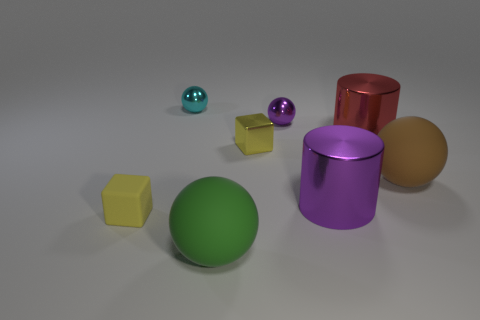Subtract 1 balls. How many balls are left? 3 Subtract all blue balls. Subtract all brown cylinders. How many balls are left? 4 Add 1 red objects. How many objects exist? 9 Subtract all blocks. How many objects are left? 6 Add 7 big purple metallic objects. How many big purple metallic objects are left? 8 Add 8 big green cubes. How many big green cubes exist? 8 Subtract 0 brown cubes. How many objects are left? 8 Subtract all tiny brown cylinders. Subtract all big purple cylinders. How many objects are left? 7 